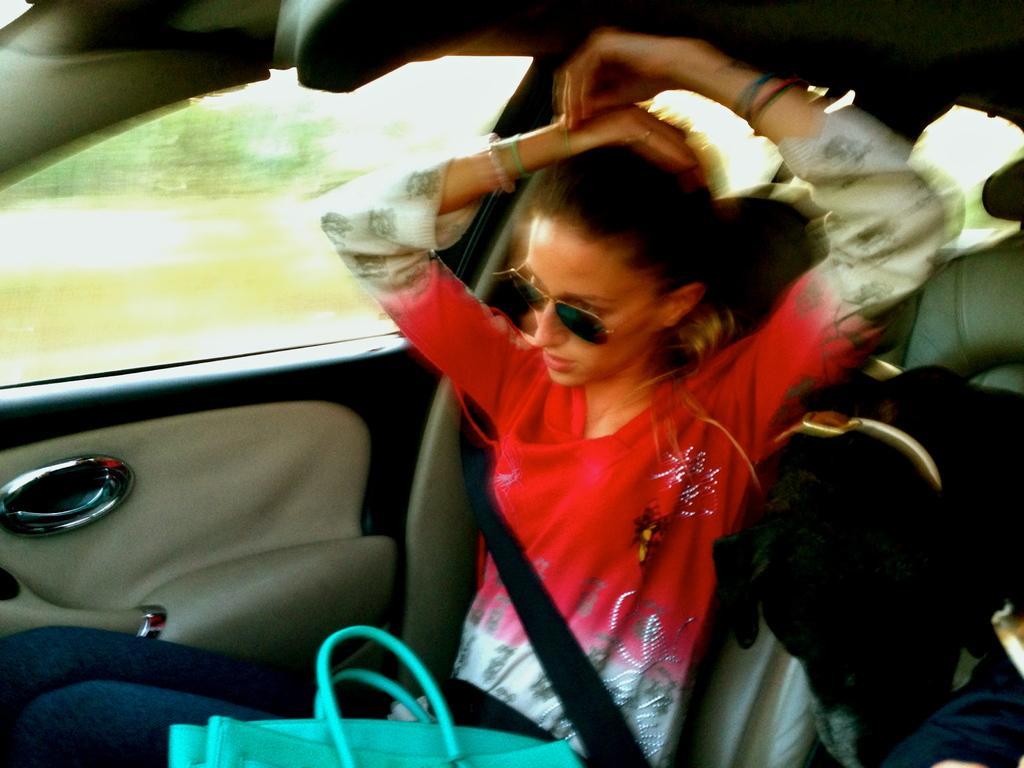Could you give a brief overview of what you see in this image? In this picture I can see a woman and a dog inside a vehicle and there is a bag. 